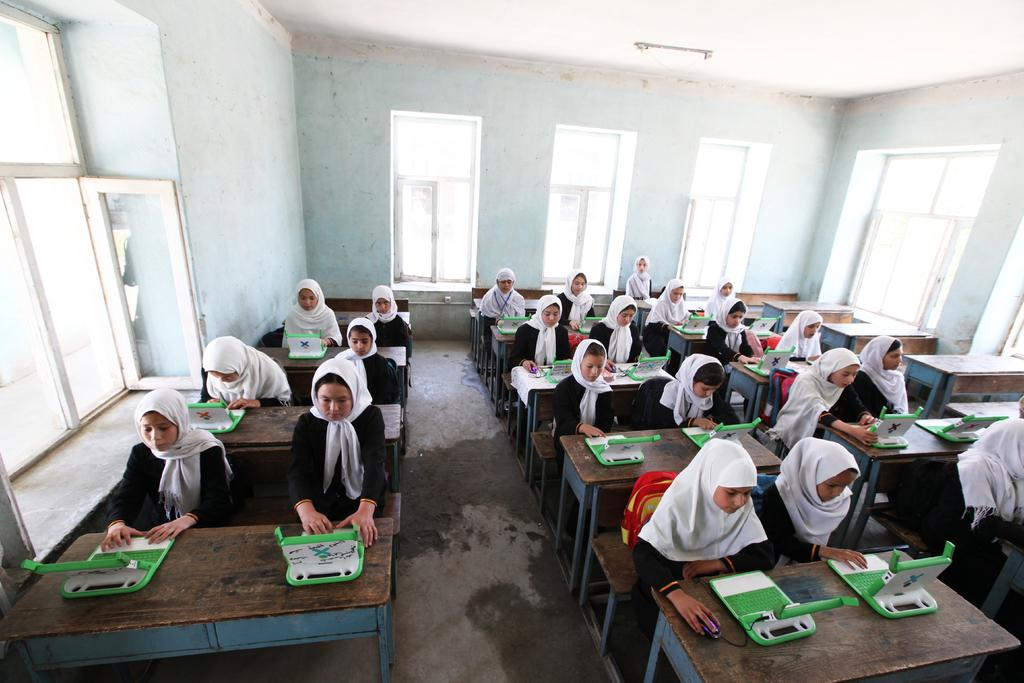What can be seen in the image? There is a group of students in the image. How are the students positioned in the image? The students are sitting on benches. What are the students doing while sitting on the benches? The students are working in front of devices. What is visible in the background of the image? There is a white wall and windows visible in the background of the image. What type of hand can be seen holding a device in the image? There is no hand holding a device in the image; the students are working in front of devices, but their hands are not visible. 